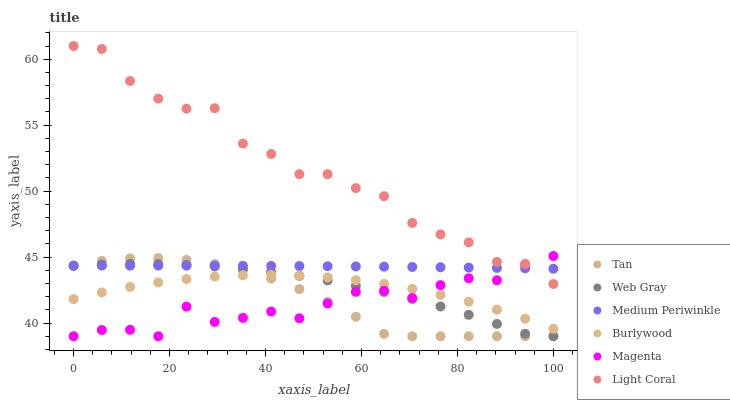Does Magenta have the minimum area under the curve?
Answer yes or no. Yes. Does Light Coral have the maximum area under the curve?
Answer yes or no. Yes. Does Burlywood have the minimum area under the curve?
Answer yes or no. No. Does Burlywood have the maximum area under the curve?
Answer yes or no. No. Is Medium Periwinkle the smoothest?
Answer yes or no. Yes. Is Light Coral the roughest?
Answer yes or no. Yes. Is Burlywood the smoothest?
Answer yes or no. No. Is Burlywood the roughest?
Answer yes or no. No. Does Web Gray have the lowest value?
Answer yes or no. Yes. Does Burlywood have the lowest value?
Answer yes or no. No. Does Light Coral have the highest value?
Answer yes or no. Yes. Does Medium Periwinkle have the highest value?
Answer yes or no. No. Is Burlywood less than Light Coral?
Answer yes or no. Yes. Is Medium Periwinkle greater than Burlywood?
Answer yes or no. Yes. Does Magenta intersect Web Gray?
Answer yes or no. Yes. Is Magenta less than Web Gray?
Answer yes or no. No. Is Magenta greater than Web Gray?
Answer yes or no. No. Does Burlywood intersect Light Coral?
Answer yes or no. No. 